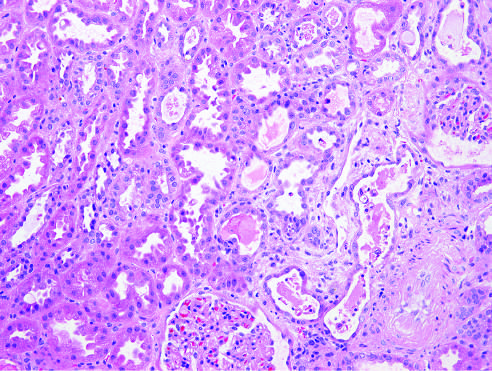whose underlying basement membranes is detachment of tubular cells from, and granular casts?
Answer the question using a single word or phrase. Their 